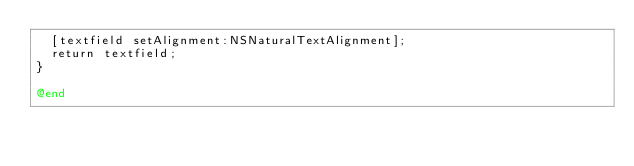Convert code to text. <code><loc_0><loc_0><loc_500><loc_500><_ObjectiveC_>  [textfield setAlignment:NSNaturalTextAlignment];
  return textfield;
}

@end
</code> 